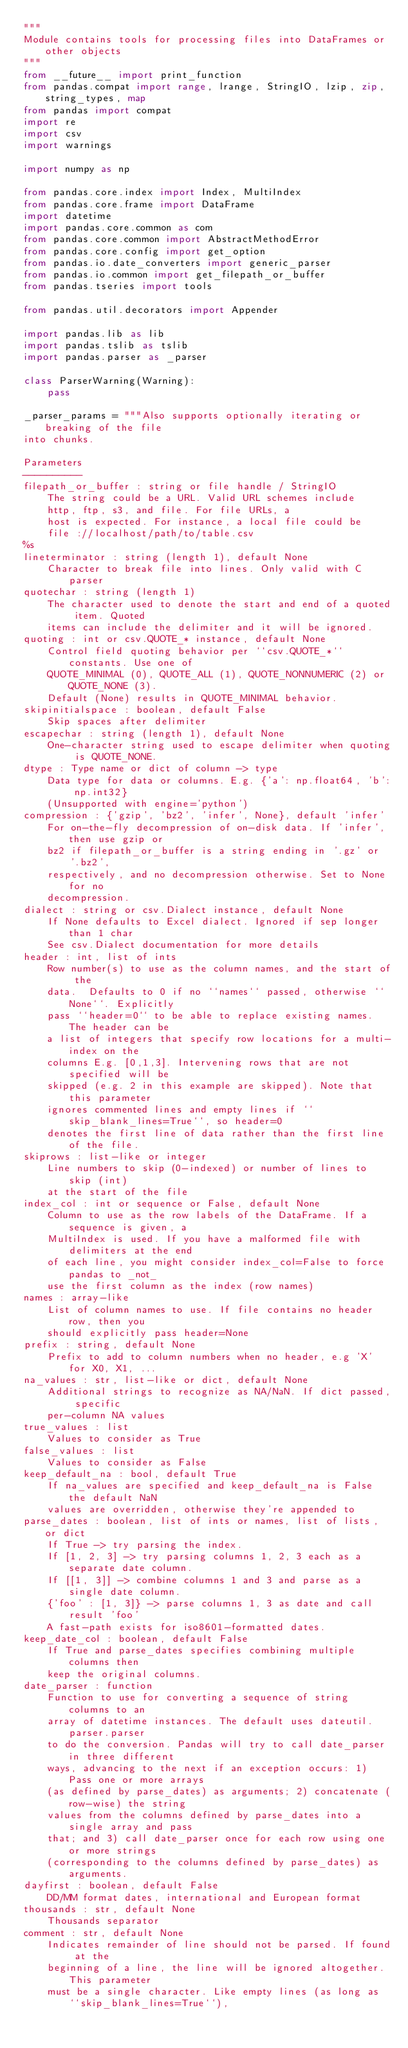Convert code to text. <code><loc_0><loc_0><loc_500><loc_500><_Python_>"""
Module contains tools for processing files into DataFrames or other objects
"""
from __future__ import print_function
from pandas.compat import range, lrange, StringIO, lzip, zip, string_types, map
from pandas import compat
import re
import csv
import warnings

import numpy as np

from pandas.core.index import Index, MultiIndex
from pandas.core.frame import DataFrame
import datetime
import pandas.core.common as com
from pandas.core.common import AbstractMethodError
from pandas.core.config import get_option
from pandas.io.date_converters import generic_parser
from pandas.io.common import get_filepath_or_buffer
from pandas.tseries import tools

from pandas.util.decorators import Appender

import pandas.lib as lib
import pandas.tslib as tslib
import pandas.parser as _parser

class ParserWarning(Warning):
    pass

_parser_params = """Also supports optionally iterating or breaking of the file
into chunks.

Parameters
----------
filepath_or_buffer : string or file handle / StringIO
    The string could be a URL. Valid URL schemes include
    http, ftp, s3, and file. For file URLs, a
    host is expected. For instance, a local file could be
    file ://localhost/path/to/table.csv
%s
lineterminator : string (length 1), default None
    Character to break file into lines. Only valid with C parser
quotechar : string (length 1)
    The character used to denote the start and end of a quoted item. Quoted
    items can include the delimiter and it will be ignored.
quoting : int or csv.QUOTE_* instance, default None
    Control field quoting behavior per ``csv.QUOTE_*`` constants. Use one of
    QUOTE_MINIMAL (0), QUOTE_ALL (1), QUOTE_NONNUMERIC (2) or QUOTE_NONE (3).
    Default (None) results in QUOTE_MINIMAL behavior.
skipinitialspace : boolean, default False
    Skip spaces after delimiter
escapechar : string (length 1), default None
    One-character string used to escape delimiter when quoting is QUOTE_NONE.
dtype : Type name or dict of column -> type
    Data type for data or columns. E.g. {'a': np.float64, 'b': np.int32}
    (Unsupported with engine='python')
compression : {'gzip', 'bz2', 'infer', None}, default 'infer'
    For on-the-fly decompression of on-disk data. If 'infer', then use gzip or
    bz2 if filepath_or_buffer is a string ending in '.gz' or '.bz2',
    respectively, and no decompression otherwise. Set to None for no
    decompression.
dialect : string or csv.Dialect instance, default None
    If None defaults to Excel dialect. Ignored if sep longer than 1 char
    See csv.Dialect documentation for more details
header : int, list of ints
    Row number(s) to use as the column names, and the start of the
    data.  Defaults to 0 if no ``names`` passed, otherwise ``None``. Explicitly
    pass ``header=0`` to be able to replace existing names. The header can be
    a list of integers that specify row locations for a multi-index on the
    columns E.g. [0,1,3]. Intervening rows that are not specified will be
    skipped (e.g. 2 in this example are skipped). Note that this parameter
    ignores commented lines and empty lines if ``skip_blank_lines=True``, so header=0
    denotes the first line of data rather than the first line of the file.
skiprows : list-like or integer
    Line numbers to skip (0-indexed) or number of lines to skip (int)
    at the start of the file
index_col : int or sequence or False, default None
    Column to use as the row labels of the DataFrame. If a sequence is given, a
    MultiIndex is used. If you have a malformed file with delimiters at the end
    of each line, you might consider index_col=False to force pandas to _not_
    use the first column as the index (row names)
names : array-like
    List of column names to use. If file contains no header row, then you
    should explicitly pass header=None
prefix : string, default None
    Prefix to add to column numbers when no header, e.g 'X' for X0, X1, ...
na_values : str, list-like or dict, default None
    Additional strings to recognize as NA/NaN. If dict passed, specific
    per-column NA values
true_values : list
    Values to consider as True
false_values : list
    Values to consider as False
keep_default_na : bool, default True
    If na_values are specified and keep_default_na is False the default NaN
    values are overridden, otherwise they're appended to
parse_dates : boolean, list of ints or names, list of lists, or dict
    If True -> try parsing the index.
    If [1, 2, 3] -> try parsing columns 1, 2, 3 each as a separate date column.
    If [[1, 3]] -> combine columns 1 and 3 and parse as a single date column.
    {'foo' : [1, 3]} -> parse columns 1, 3 as date and call result 'foo'
    A fast-path exists for iso8601-formatted dates.
keep_date_col : boolean, default False
    If True and parse_dates specifies combining multiple columns then
    keep the original columns.
date_parser : function
    Function to use for converting a sequence of string columns to an
    array of datetime instances. The default uses dateutil.parser.parser
    to do the conversion. Pandas will try to call date_parser in three different
    ways, advancing to the next if an exception occurs: 1) Pass one or more arrays
    (as defined by parse_dates) as arguments; 2) concatenate (row-wise) the string
    values from the columns defined by parse_dates into a single array and pass
    that; and 3) call date_parser once for each row using one or more strings
    (corresponding to the columns defined by parse_dates) as arguments.
dayfirst : boolean, default False
    DD/MM format dates, international and European format
thousands : str, default None
    Thousands separator
comment : str, default None
    Indicates remainder of line should not be parsed. If found at the
    beginning of a line, the line will be ignored altogether. This parameter
    must be a single character. Like empty lines (as long as ``skip_blank_lines=True``),</code> 